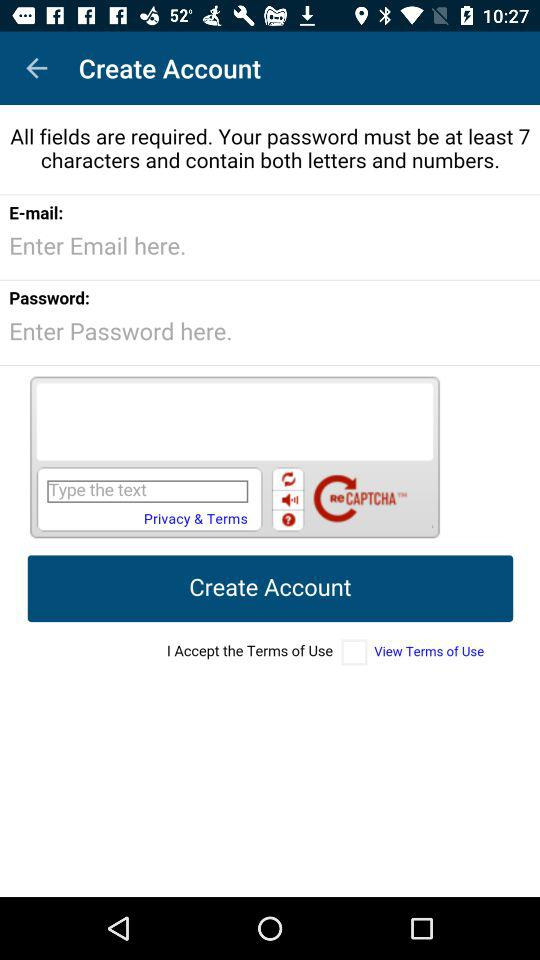How can we create an account?
When the provided information is insufficient, respond with <no answer>. <no answer> 